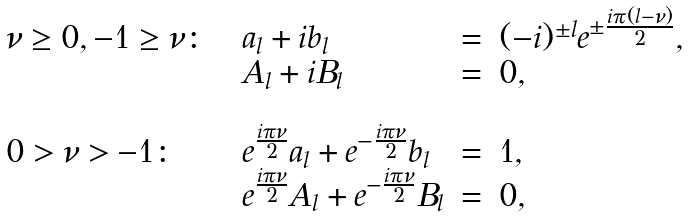Convert formula to latex. <formula><loc_0><loc_0><loc_500><loc_500>\begin{array} { l c l c l } \nu \geq 0 , - 1 \geq \nu \colon & & a _ { l } + i b _ { l } & = & ( - i ) ^ { \pm l } e ^ { \pm \frac { i \pi ( l - \nu ) } { 2 } } , \\ & & A _ { l } + i B _ { l } & = & 0 , \\ & & & & \\ 0 > \nu > - 1 \colon & & e ^ { \frac { i \pi \nu } { 2 } } a _ { l } + e ^ { - \frac { i \pi \nu } { 2 } } b _ { l } & = & 1 , \\ & & e ^ { \frac { i \pi \nu } { 2 } } A _ { l } + e ^ { - \frac { i \pi \nu } { 2 } } B _ { l } & = & 0 , \\ \end{array}</formula> 